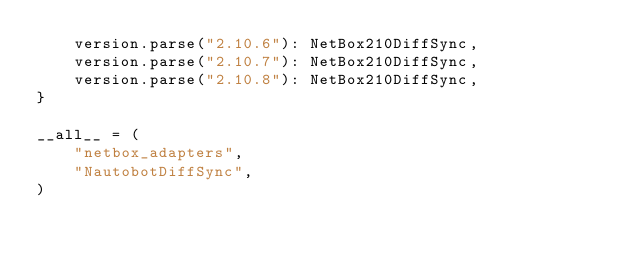Convert code to text. <code><loc_0><loc_0><loc_500><loc_500><_Python_>    version.parse("2.10.6"): NetBox210DiffSync,
    version.parse("2.10.7"): NetBox210DiffSync,
    version.parse("2.10.8"): NetBox210DiffSync,
}

__all__ = (
    "netbox_adapters",
    "NautobotDiffSync",
)
</code> 